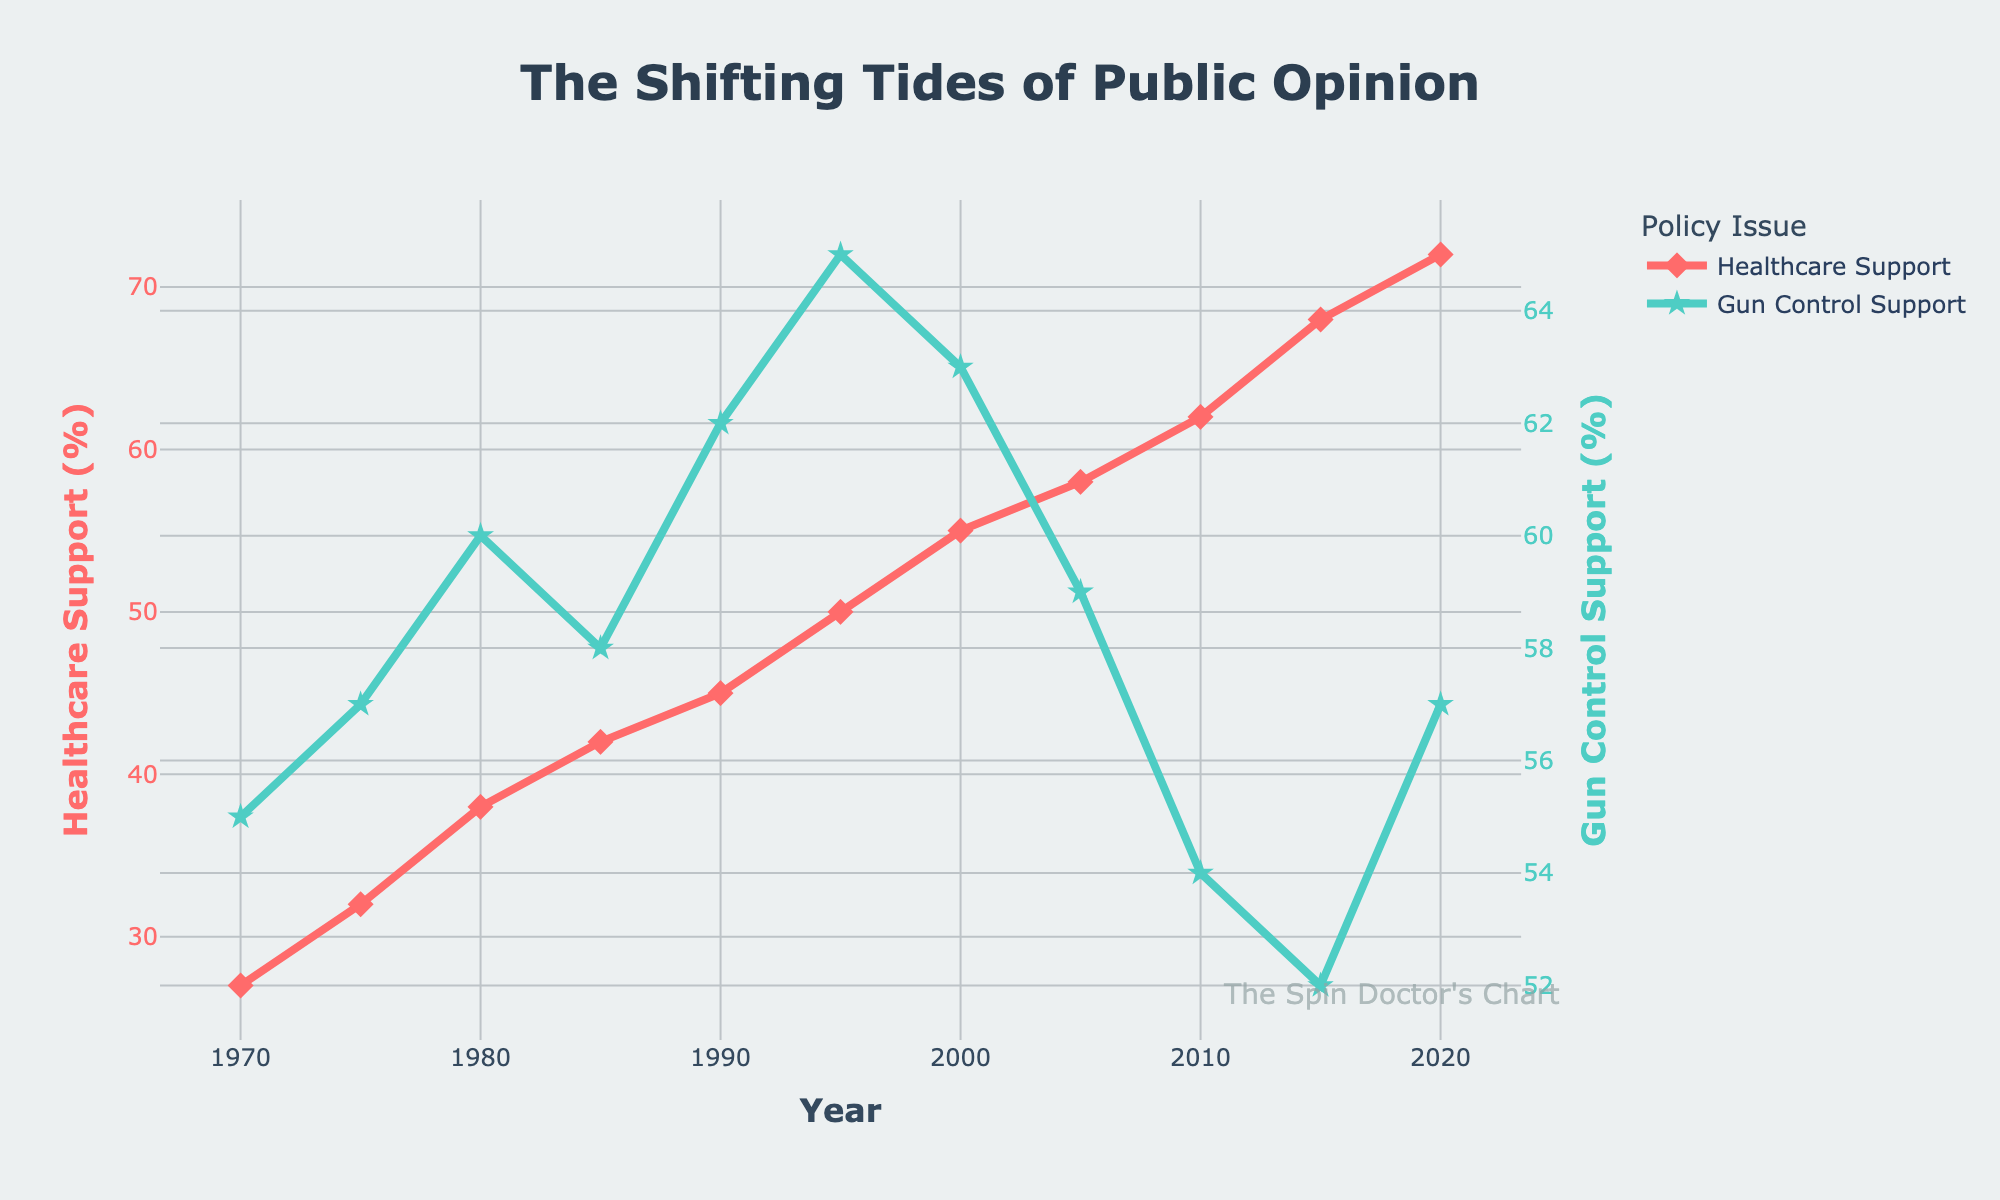What is the trend for healthcare support over the last 50 years? From 1970 to 2020, healthcare support has continuously increased, starting at 27% in 1970 and rising to 72% in 2020.
Answer: Continuous increase Which year saw the highest support for gun control? In 1995, gun control support reached its highest at 65%.
Answer: 1995 By how many percentage points did healthcare support change from 2000 to 2020? Healthcare support was 55% in 2000 and increased to 72% in 2020. The change is 72% - 55% = 17 percentage points.
Answer: 17 Compare the healthcare and gun control support in 1985. Which one had more support and by how much? In 1985, healthcare support was 42%, and gun control support was 58%. Gun control had 58% - 42% = 16% more support than healthcare.
Answer: Gun control by 16% What is the overall change in gun control support from its highest point to its lowest point? The highest gun control support was 65% in 1995, and the lowest was 52% in 2015. The overall change is 65% - 52% = 13 percentage points.
Answer: 13 What is the overall change in healthcare support from its lowest point to its highest point? The lowest healthcare support was 27% in 1970, and the highest was 72% in 2020. The overall change is 72% - 27% = 45 percentage points.
Answer: 45 In which decade did healthcare support see the most significant increase? From 2010 to 2020, healthcare support increased from 62% to 72%, a 10 percentage-point increase. This is the largest increase compared to other decades.
Answer: 2010s Between 2005 and 2010, which policy saw a more significant change in public support, and by how many percentage points? Healthcare support increased from 58% to 62% (a 4% increase), while gun control support decreased from 59% to 54% (a 5% decrease). Gun control saw a more significant change by 1 percentage point.
Answer: Gun control by 1 Between 1970 and 2000, which support grew faster, healthcare or gun control? Healthcare support grew from 27% to 55% (28 percentage points), while gun control support grew from 55% to 63% (8 percentage points). Healthcare support grew faster by 20 percentage points.
Answer: Healthcare by 20 